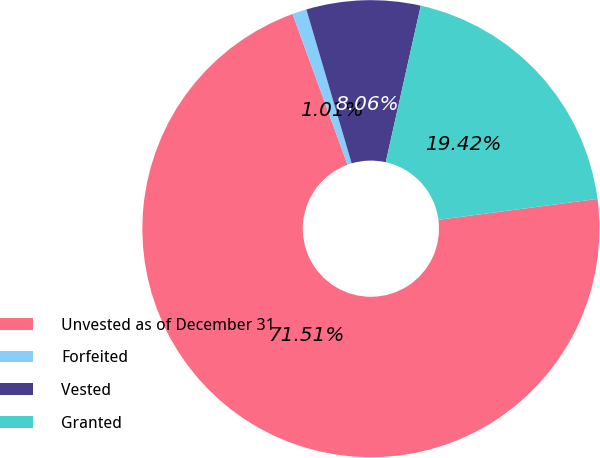Convert chart to OTSL. <chart><loc_0><loc_0><loc_500><loc_500><pie_chart><fcel>Unvested as of December 31<fcel>Forfeited<fcel>Vested<fcel>Granted<nl><fcel>71.52%<fcel>1.01%<fcel>8.06%<fcel>19.42%<nl></chart> 